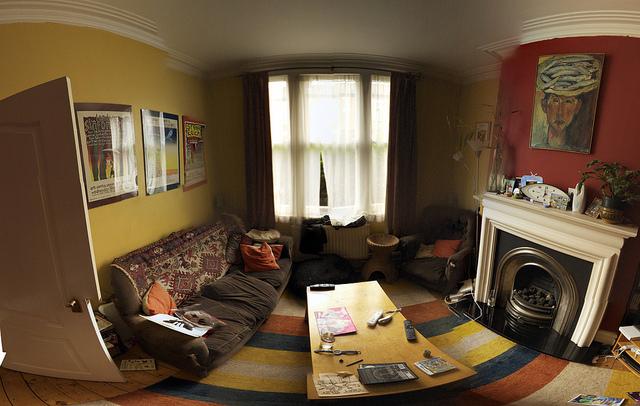Is this area neat?
Give a very brief answer. Yes. Is there a fire in the fireplace?
Short answer required. No. What is the reflective object in the fireplace?
Be succinct. Metal. What do you call the effect used to make this picture?
Give a very brief answer. Fisheye. How much does the sofa weigh?
Answer briefly. 100. Is the room messing?
Answer briefly. No. What is on the arm chair of the couch?
Give a very brief answer. Paper. Is there a fan on the ceiling?
Concise answer only. No. How many pillows are on the couch?
Answer briefly. 2. What is on the wall above the mantel?
Quick response, please. Painting. Why would the people who live in the house face their sofa in this direction?
Give a very brief answer. Fireplace. How many tables are in the picture?
Short answer required. 1. 